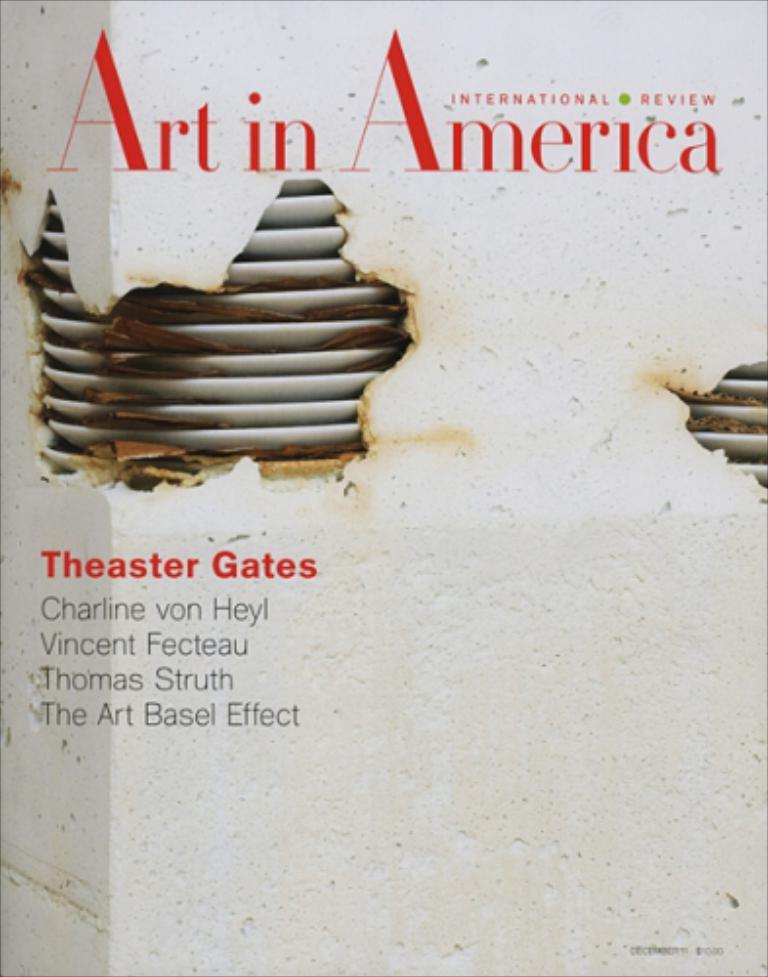<image>
Present a compact description of the photo's key features. A book titled Art in America by Theaster Gates. 